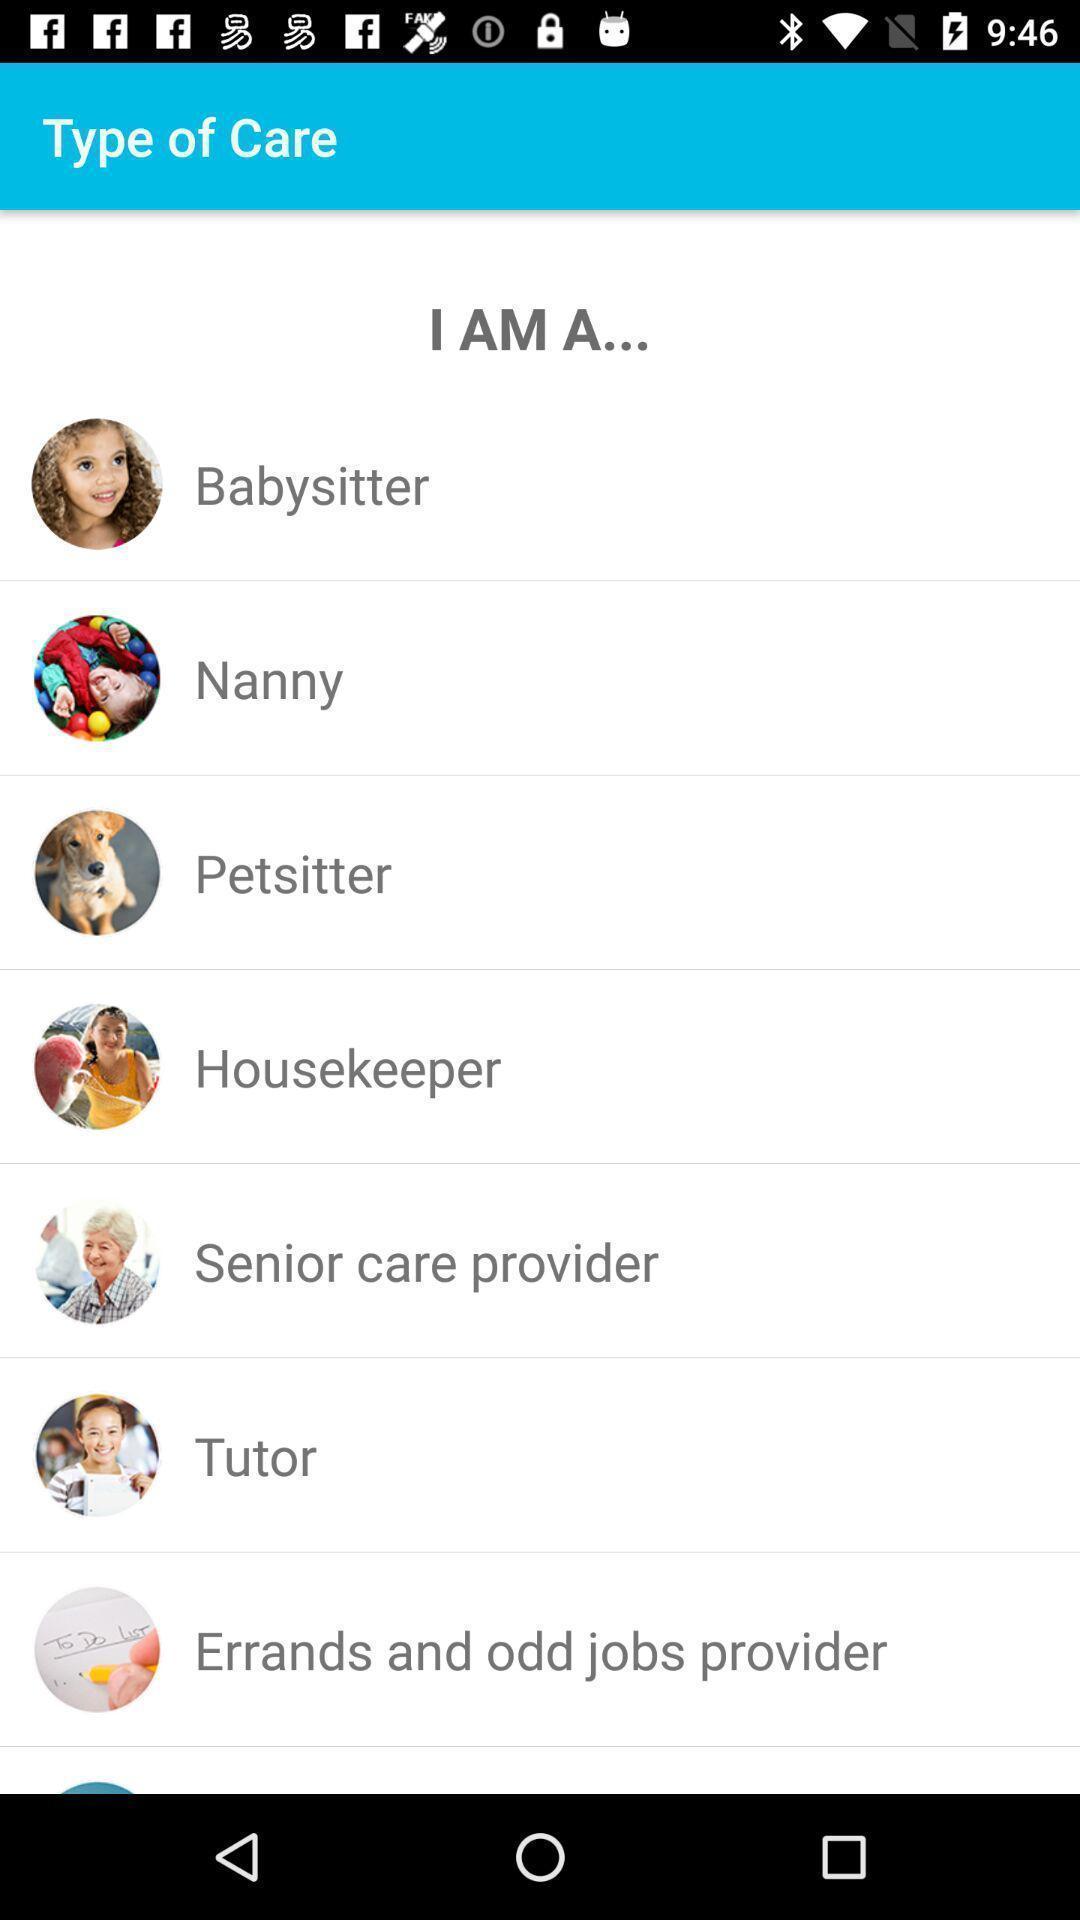Please provide a description for this image. Screen displaying list of caregivers in our local area. 